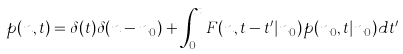<formula> <loc_0><loc_0><loc_500><loc_500>p ( n , t ) = \delta ( t ) \delta ( n - n _ { 0 } ) + \int _ { 0 } ^ { t } F ( n , t - t ^ { \prime } | n _ { 0 } ) p ( n _ { 0 } , t | n _ { 0 } ) d t ^ { \prime }</formula> 